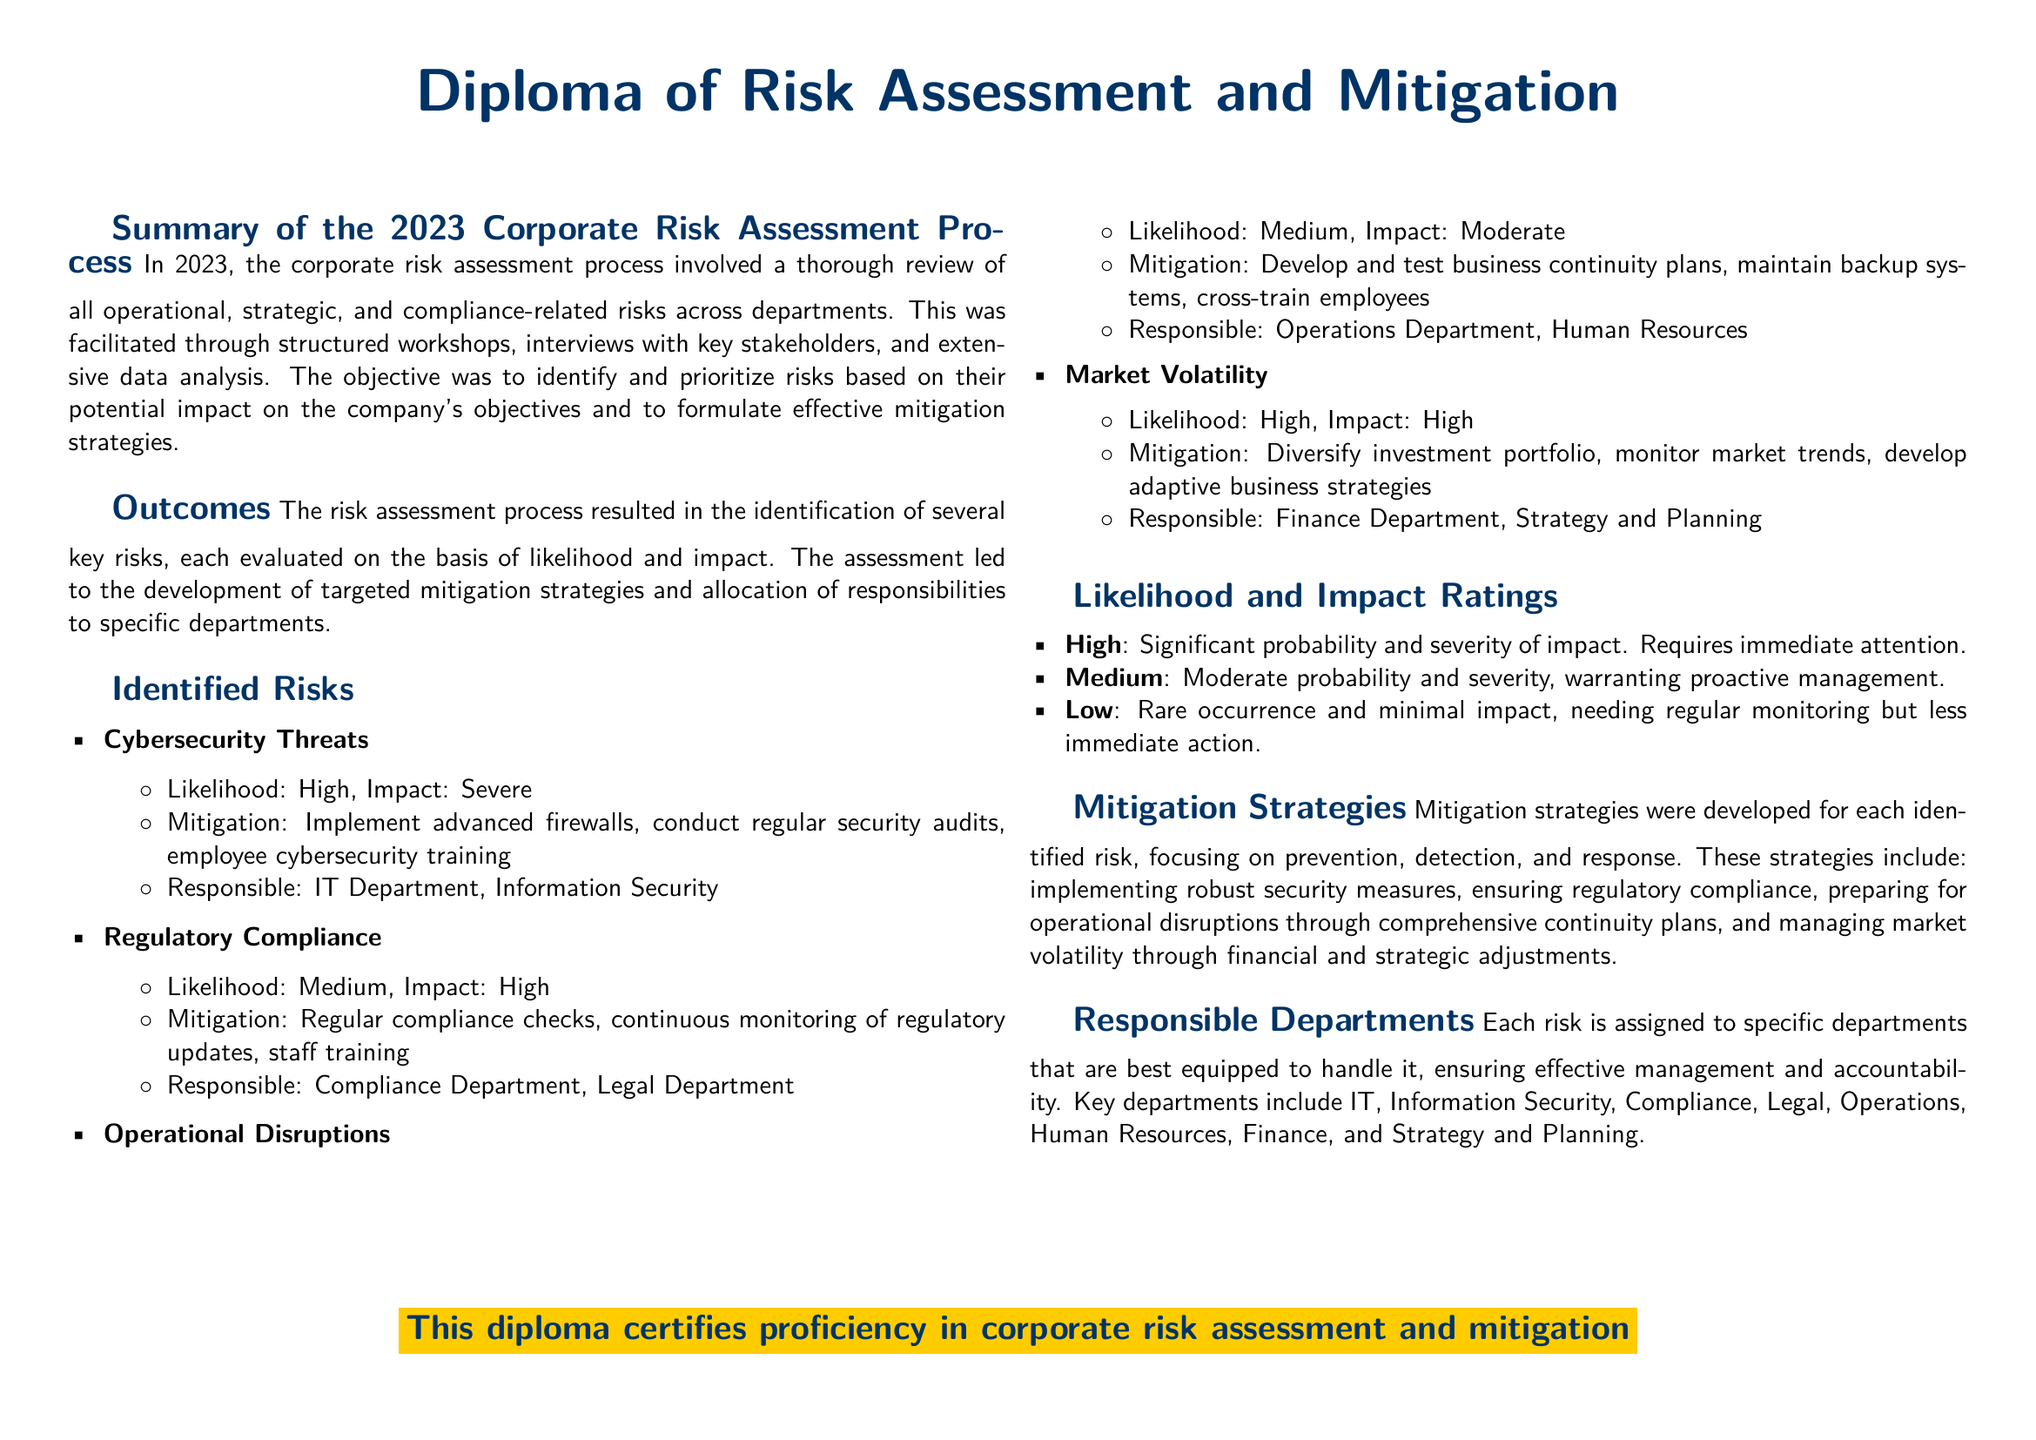what is the title of the diploma? The title of the diploma is presented at the top of the document.
Answer: Diploma of Risk Assessment and Mitigation what was the likelihood and impact of cybersecurity threats? The document specifies both the likelihood and impact ratings for cybersecurity threats in the identified risks section.
Answer: High, Severe which department is responsible for regulatory compliance? The responsible department for regulatory compliance is mentioned in the mitigation strategies section.
Answer: Compliance Department, Legal Department what mitigation strategy is suggested for operational disruptions? The document lists specific mitigation strategies for each identified risk under the outcomes section.
Answer: Develop and test business continuity plans how many key risks were identified in the assessment process? The number of key risks is mentioned in the outcomes section of the diploma.
Answer: Four what is the impact rating for market volatility? The impact rating for market volatility is found in the identified risks section of the document.
Answer: High which departments are tasked with managing cybersecurity threats? The departments assigned to manage this risk are specified in the identified risks section.
Answer: IT Department, Information Security what does a 'High' likelihood rating signify according to the document? The explanation of a 'High' likelihood rating can be found in the likelihood and impact ratings section.
Answer: Significant probability and severity of impact what are the two strategies mentioned to mitigate market volatility? The strategies for market volatility are outlined in the identified risks section.
Answer: Diversify investment portfolio, monitor market trends 